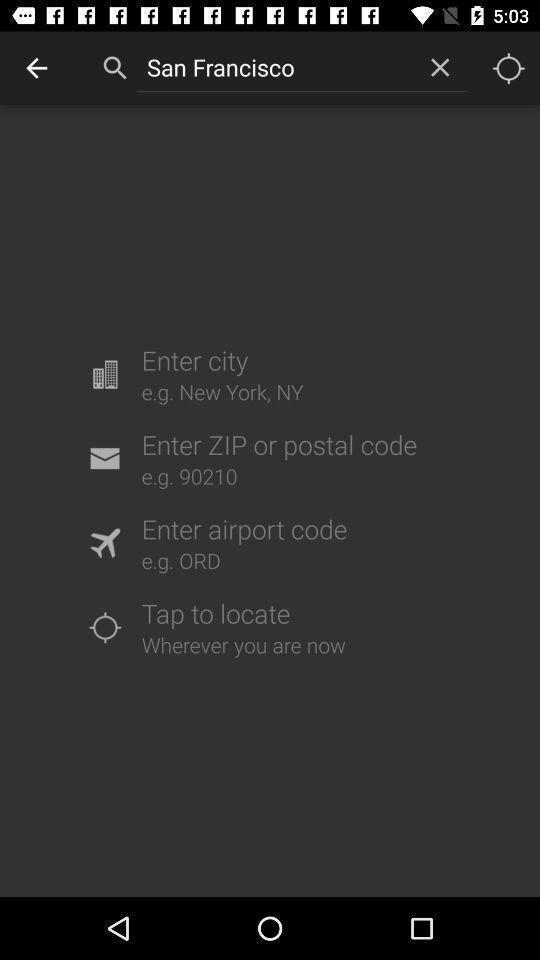Describe the content in this image. Search page asking to enter location in weather updates application. 